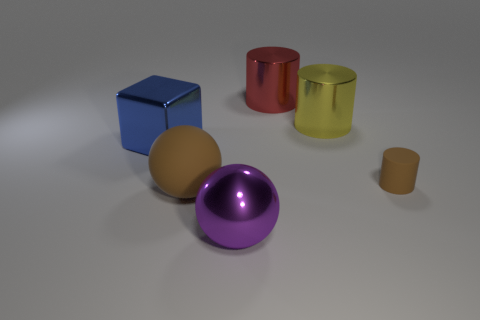Is the number of red objects right of the matte cylinder the same as the number of large yellow matte balls? Indeed, the number of red objects positioned to the right of the matte cylinder, which is the red cup, is exactly one. This matches the number of large yellow matte balls present in the image, which is also one. Thus, there is a one-to-one correlation between the red objects to the right of the matte cylinder and the large yellow matte balls. 